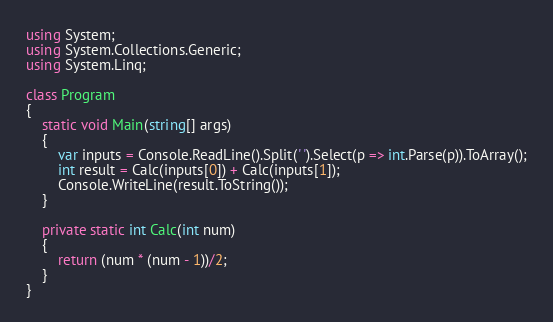Convert code to text. <code><loc_0><loc_0><loc_500><loc_500><_C#_>using System;
using System.Collections.Generic;
using System.Linq;

class Program
{
	static void Main(string[] args)
	{
		var inputs = Console.ReadLine().Split(' ').Select(p => int.Parse(p)).ToArray();
		int result = Calc(inputs[0]) + Calc(inputs[1]);
		Console.WriteLine(result.ToString());
	}

	private static int Calc(int num)
	{
		return (num * (num - 1))/2;
	}
}
</code> 